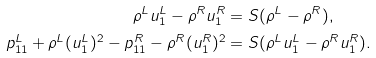<formula> <loc_0><loc_0><loc_500><loc_500>\rho ^ { L } u _ { 1 } ^ { L } - \rho ^ { R } u _ { 1 } ^ { R } & = S ( \rho ^ { L } - \rho ^ { R } ) , \\ p _ { 1 1 } ^ { L } + \rho ^ { L } ( u _ { 1 } ^ { L } ) ^ { 2 } - p _ { 1 1 } ^ { R } - \rho ^ { R } ( u _ { 1 } ^ { R } ) ^ { 2 } & = S ( \rho ^ { L } u _ { 1 } ^ { L } - \rho ^ { R } u _ { 1 } ^ { R } ) .</formula> 